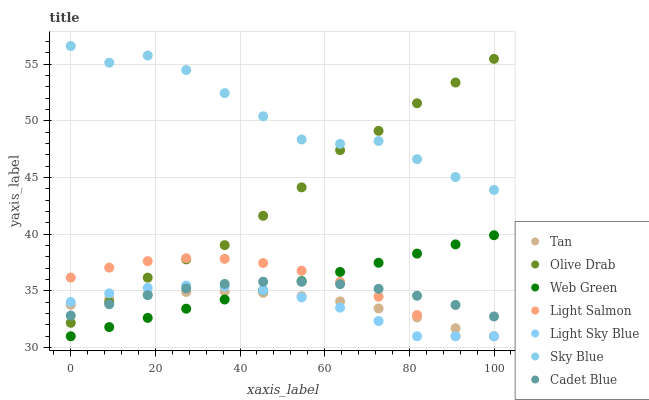Does Light Sky Blue have the minimum area under the curve?
Answer yes or no. Yes. Does Sky Blue have the maximum area under the curve?
Answer yes or no. Yes. Does Cadet Blue have the minimum area under the curve?
Answer yes or no. No. Does Cadet Blue have the maximum area under the curve?
Answer yes or no. No. Is Web Green the smoothest?
Answer yes or no. Yes. Is Sky Blue the roughest?
Answer yes or no. Yes. Is Cadet Blue the smoothest?
Answer yes or no. No. Is Cadet Blue the roughest?
Answer yes or no. No. Does Light Salmon have the lowest value?
Answer yes or no. Yes. Does Cadet Blue have the lowest value?
Answer yes or no. No. Does Sky Blue have the highest value?
Answer yes or no. Yes. Does Cadet Blue have the highest value?
Answer yes or no. No. Is Tan less than Sky Blue?
Answer yes or no. Yes. Is Sky Blue greater than Web Green?
Answer yes or no. Yes. Does Cadet Blue intersect Web Green?
Answer yes or no. Yes. Is Cadet Blue less than Web Green?
Answer yes or no. No. Is Cadet Blue greater than Web Green?
Answer yes or no. No. Does Tan intersect Sky Blue?
Answer yes or no. No. 